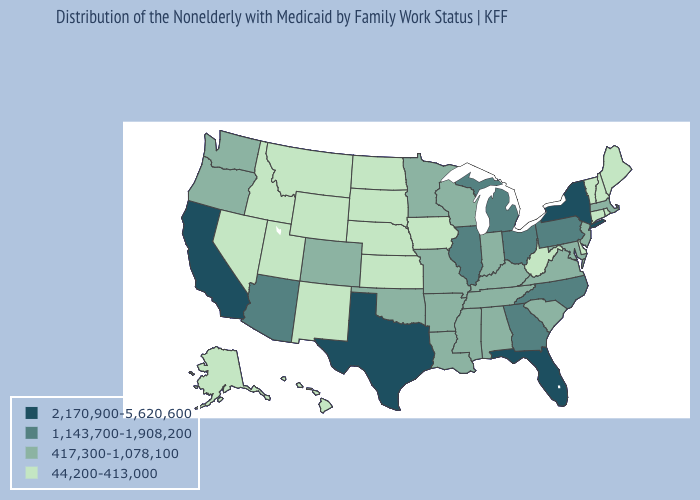Name the states that have a value in the range 1,143,700-1,908,200?
Concise answer only. Arizona, Georgia, Illinois, Michigan, North Carolina, Ohio, Pennsylvania. Name the states that have a value in the range 44,200-413,000?
Short answer required. Alaska, Connecticut, Delaware, Hawaii, Idaho, Iowa, Kansas, Maine, Montana, Nebraska, Nevada, New Hampshire, New Mexico, North Dakota, Rhode Island, South Dakota, Utah, Vermont, West Virginia, Wyoming. What is the value of Alaska?
Keep it brief. 44,200-413,000. What is the lowest value in the USA?
Concise answer only. 44,200-413,000. What is the value of Rhode Island?
Write a very short answer. 44,200-413,000. Name the states that have a value in the range 44,200-413,000?
Short answer required. Alaska, Connecticut, Delaware, Hawaii, Idaho, Iowa, Kansas, Maine, Montana, Nebraska, Nevada, New Hampshire, New Mexico, North Dakota, Rhode Island, South Dakota, Utah, Vermont, West Virginia, Wyoming. What is the value of Montana?
Answer briefly. 44,200-413,000. Among the states that border Tennessee , does Alabama have the highest value?
Give a very brief answer. No. Which states have the lowest value in the USA?
Concise answer only. Alaska, Connecticut, Delaware, Hawaii, Idaho, Iowa, Kansas, Maine, Montana, Nebraska, Nevada, New Hampshire, New Mexico, North Dakota, Rhode Island, South Dakota, Utah, Vermont, West Virginia, Wyoming. What is the value of Arkansas?
Concise answer only. 417,300-1,078,100. What is the value of Alaska?
Concise answer only. 44,200-413,000. What is the value of Maine?
Keep it brief. 44,200-413,000. Name the states that have a value in the range 44,200-413,000?
Answer briefly. Alaska, Connecticut, Delaware, Hawaii, Idaho, Iowa, Kansas, Maine, Montana, Nebraska, Nevada, New Hampshire, New Mexico, North Dakota, Rhode Island, South Dakota, Utah, Vermont, West Virginia, Wyoming. What is the value of New Jersey?
Write a very short answer. 417,300-1,078,100. 